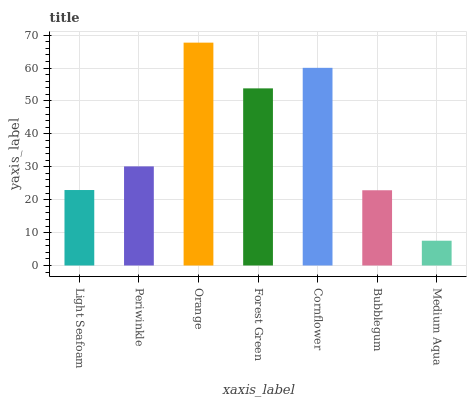Is Medium Aqua the minimum?
Answer yes or no. Yes. Is Orange the maximum?
Answer yes or no. Yes. Is Periwinkle the minimum?
Answer yes or no. No. Is Periwinkle the maximum?
Answer yes or no. No. Is Periwinkle greater than Light Seafoam?
Answer yes or no. Yes. Is Light Seafoam less than Periwinkle?
Answer yes or no. Yes. Is Light Seafoam greater than Periwinkle?
Answer yes or no. No. Is Periwinkle less than Light Seafoam?
Answer yes or no. No. Is Periwinkle the high median?
Answer yes or no. Yes. Is Periwinkle the low median?
Answer yes or no. Yes. Is Bubblegum the high median?
Answer yes or no. No. Is Forest Green the low median?
Answer yes or no. No. 